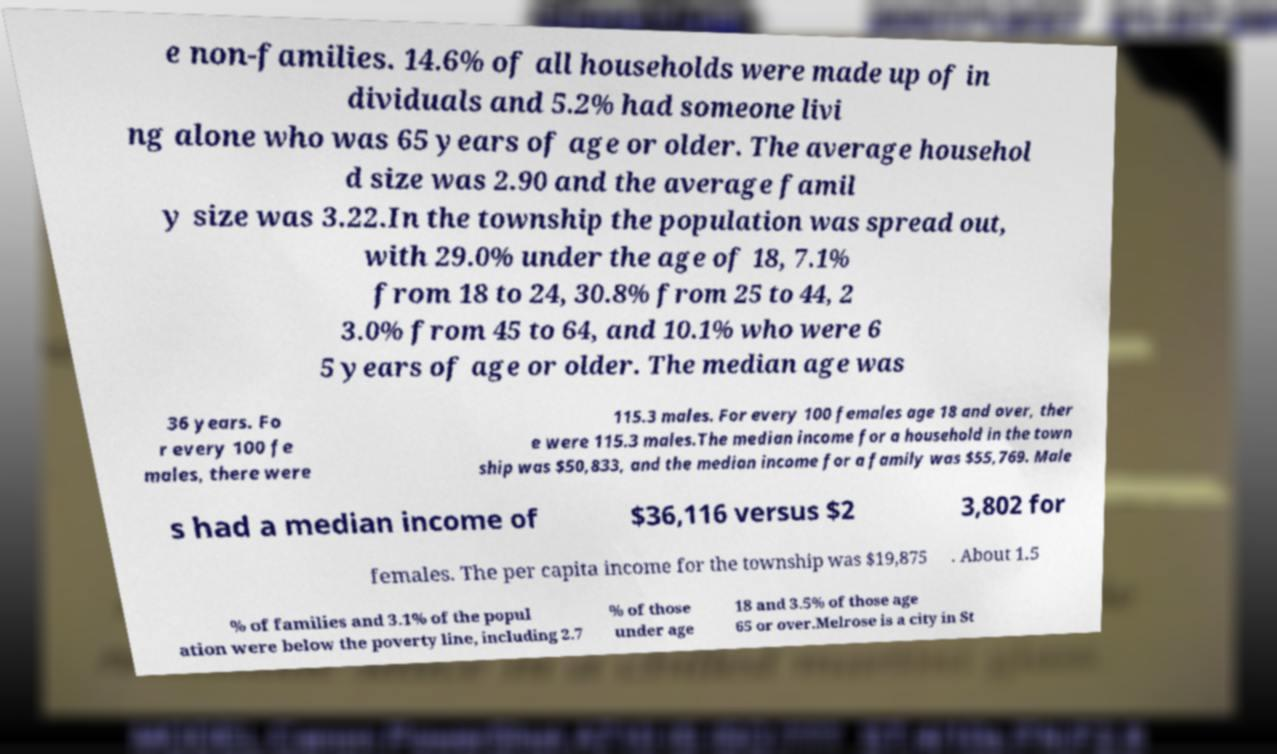Can you read and provide the text displayed in the image?This photo seems to have some interesting text. Can you extract and type it out for me? e non-families. 14.6% of all households were made up of in dividuals and 5.2% had someone livi ng alone who was 65 years of age or older. The average househol d size was 2.90 and the average famil y size was 3.22.In the township the population was spread out, with 29.0% under the age of 18, 7.1% from 18 to 24, 30.8% from 25 to 44, 2 3.0% from 45 to 64, and 10.1% who were 6 5 years of age or older. The median age was 36 years. Fo r every 100 fe males, there were 115.3 males. For every 100 females age 18 and over, ther e were 115.3 males.The median income for a household in the town ship was $50,833, and the median income for a family was $55,769. Male s had a median income of $36,116 versus $2 3,802 for females. The per capita income for the township was $19,875 . About 1.5 % of families and 3.1% of the popul ation were below the poverty line, including 2.7 % of those under age 18 and 3.5% of those age 65 or over.Melrose is a city in St 